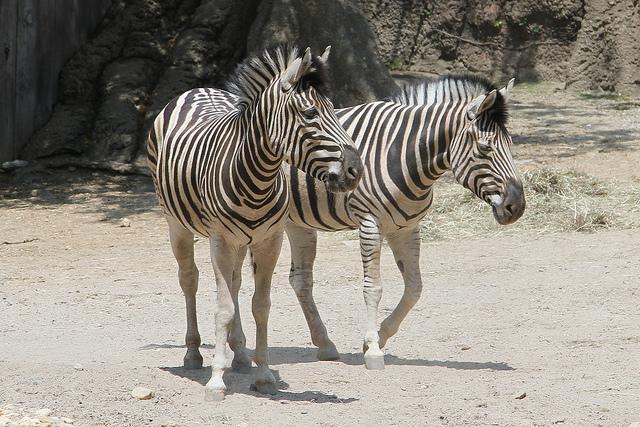How many zebras are in the photo?
Give a very brief answer. 2. How many zebras are there?
Give a very brief answer. 2. How many zebra are standing in unison?
Give a very brief answer. 2. How many zebras can be seen?
Give a very brief answer. 2. 